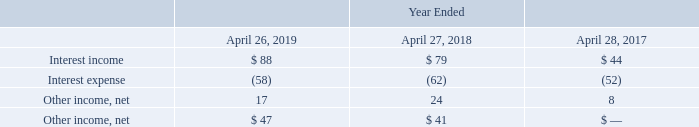8. Other income, net
Other income, net consists of the following (in millions):
Which years does the table provide information for? 2019, 2018, 2017. What was the interest income in 2019?
Answer scale should be: million. 88. What was the interest expense in 2018?
Answer scale should be: million. (62). How many years did interest income exceed $50 million? 2019##2018
Answer: 2. What was the change in interest expense between 2017 and 2018?
Answer scale should be: million. -62-(-52)
Answer: -10. What was the percentage change in Interest income between 2018 and 2019?
Answer scale should be: percent. (88-79)/79
Answer: 11.39. 